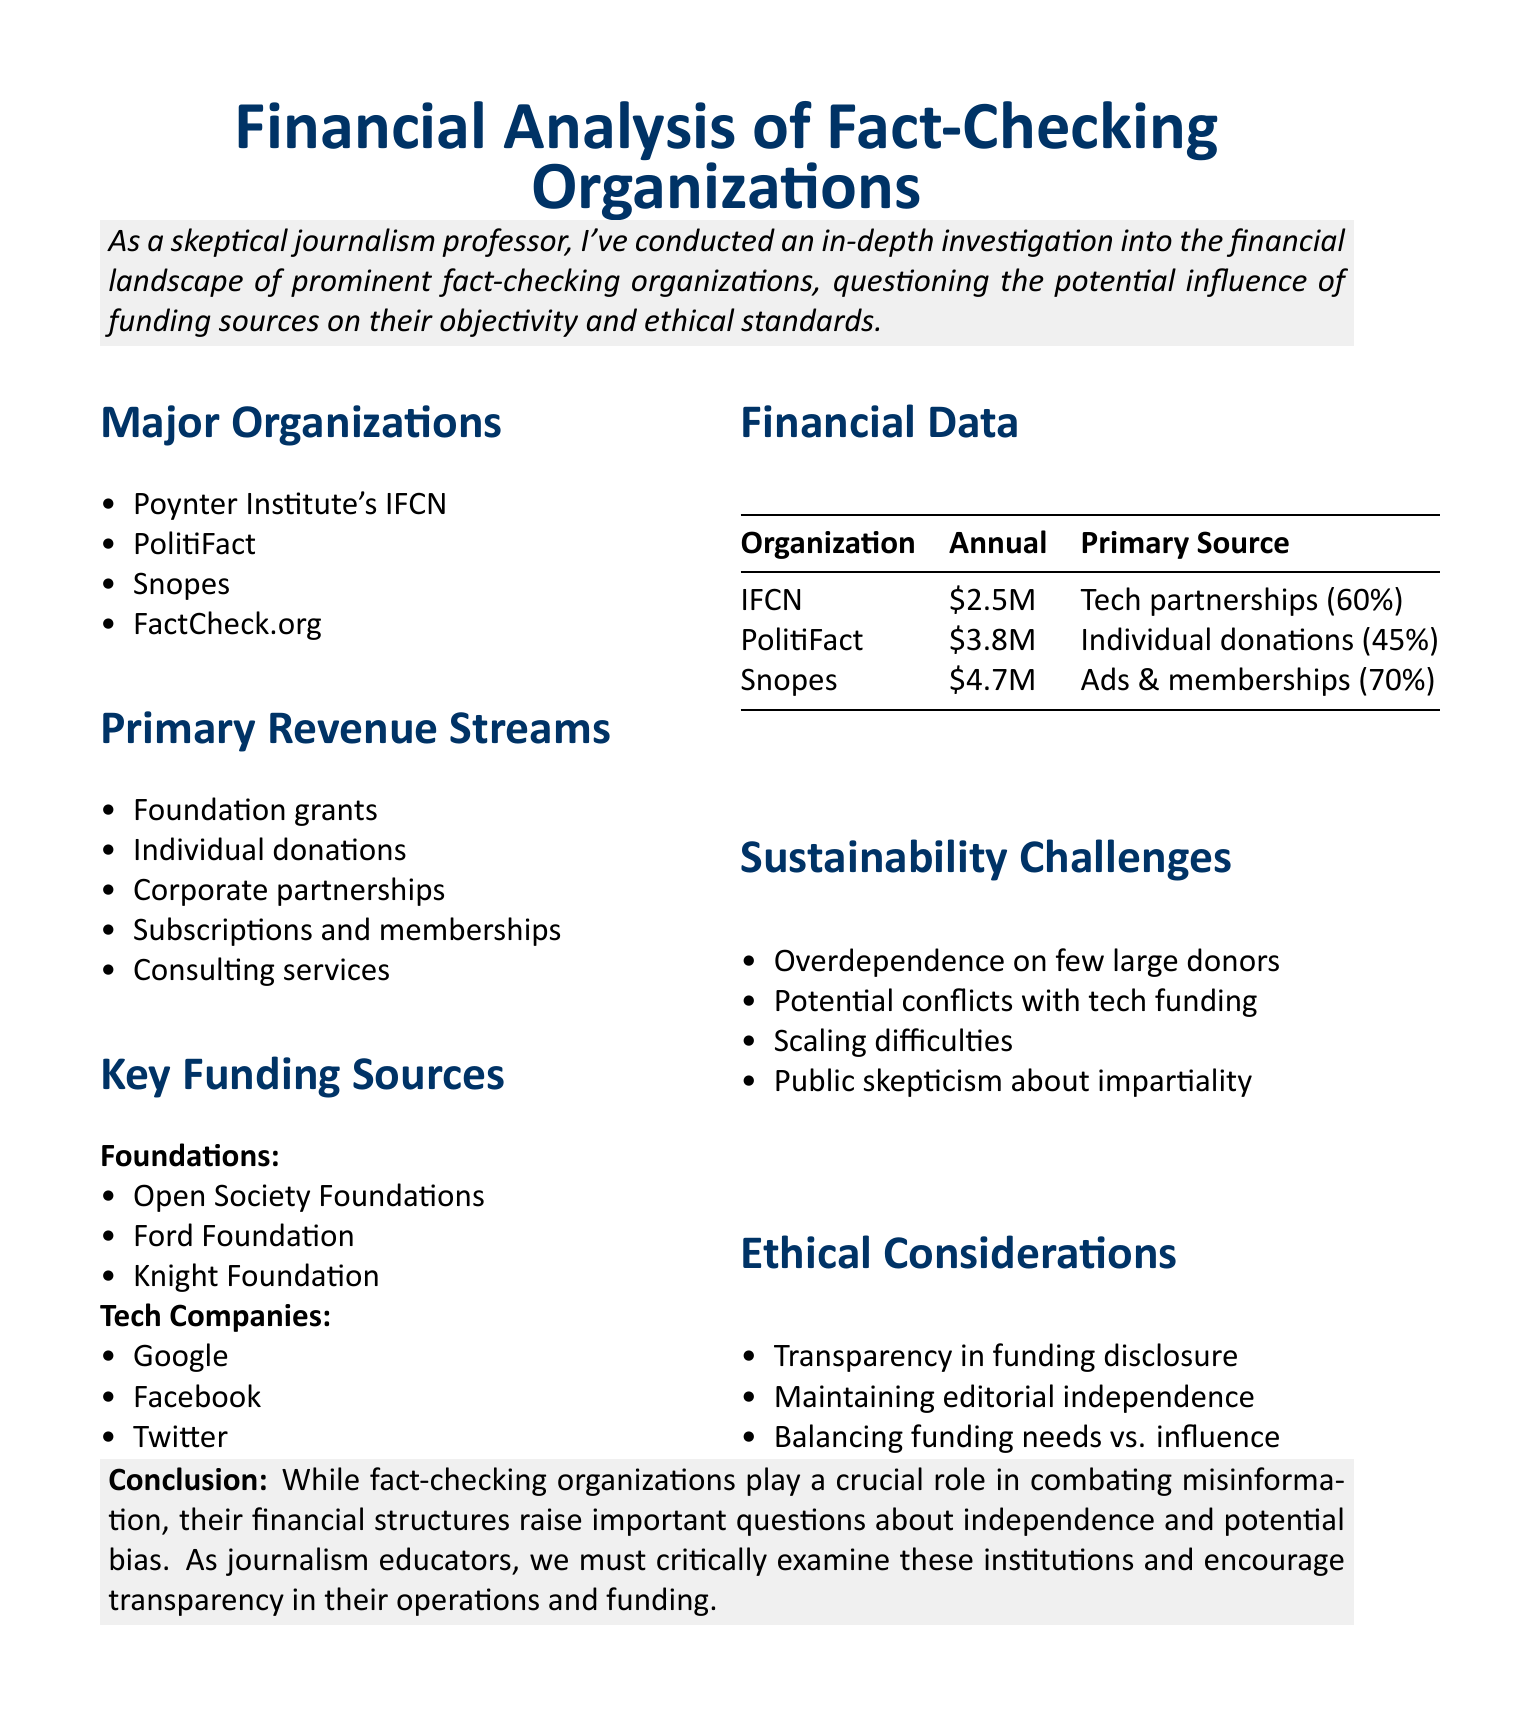What is the title of the report? The title of the report, as stated in the document, is "Financial Analysis of Fact-Checking Organizations: Revenue Streams, Funding Sources, and Sustainability Challenges."
Answer: Financial Analysis of Fact-Checking Organizations: Revenue Streams, Funding Sources, and Sustainability Challenges Which organization has the highest annual revenue? The annual revenues of the organizations in the document indicate that Snopes has the highest revenue at $4.7 million.
Answer: Snopes What percentage of the IFCN's funding comes from tech company partnerships? According to the document, the primary funding source for the IFCN is tech company partnerships, contributing 60% of its budget.
Answer: 60% What sustainability challenge is mentioned in relation to donor dependence? The document lists "Overdependence on a few large donors" as one of the sustainability challenges faced by fact-checking organizations.
Answer: Overdependence on few large donors Name one foundation that funds fact-checking organizations. The document mentions the Open Society Foundations as one of the key funding sources for fact-checking organizations.
Answer: Open Society Foundations What is listed as a potential ethical concern for fact-checking organizations? One ethical consideration mentioned is "Maintaining editorial independence despite financial pressures."
Answer: Maintaining editorial independence What is the primary source of funding for PolitiFact? The primary source of revenue for PolitiFact is identified in the financial data as "Individual donations (45%)."
Answer: Individual donations What is the annual budget of the IFCN? The financial data shows that the IFCN has an annual budget of $2.5 million.
Answer: $2.5 million 